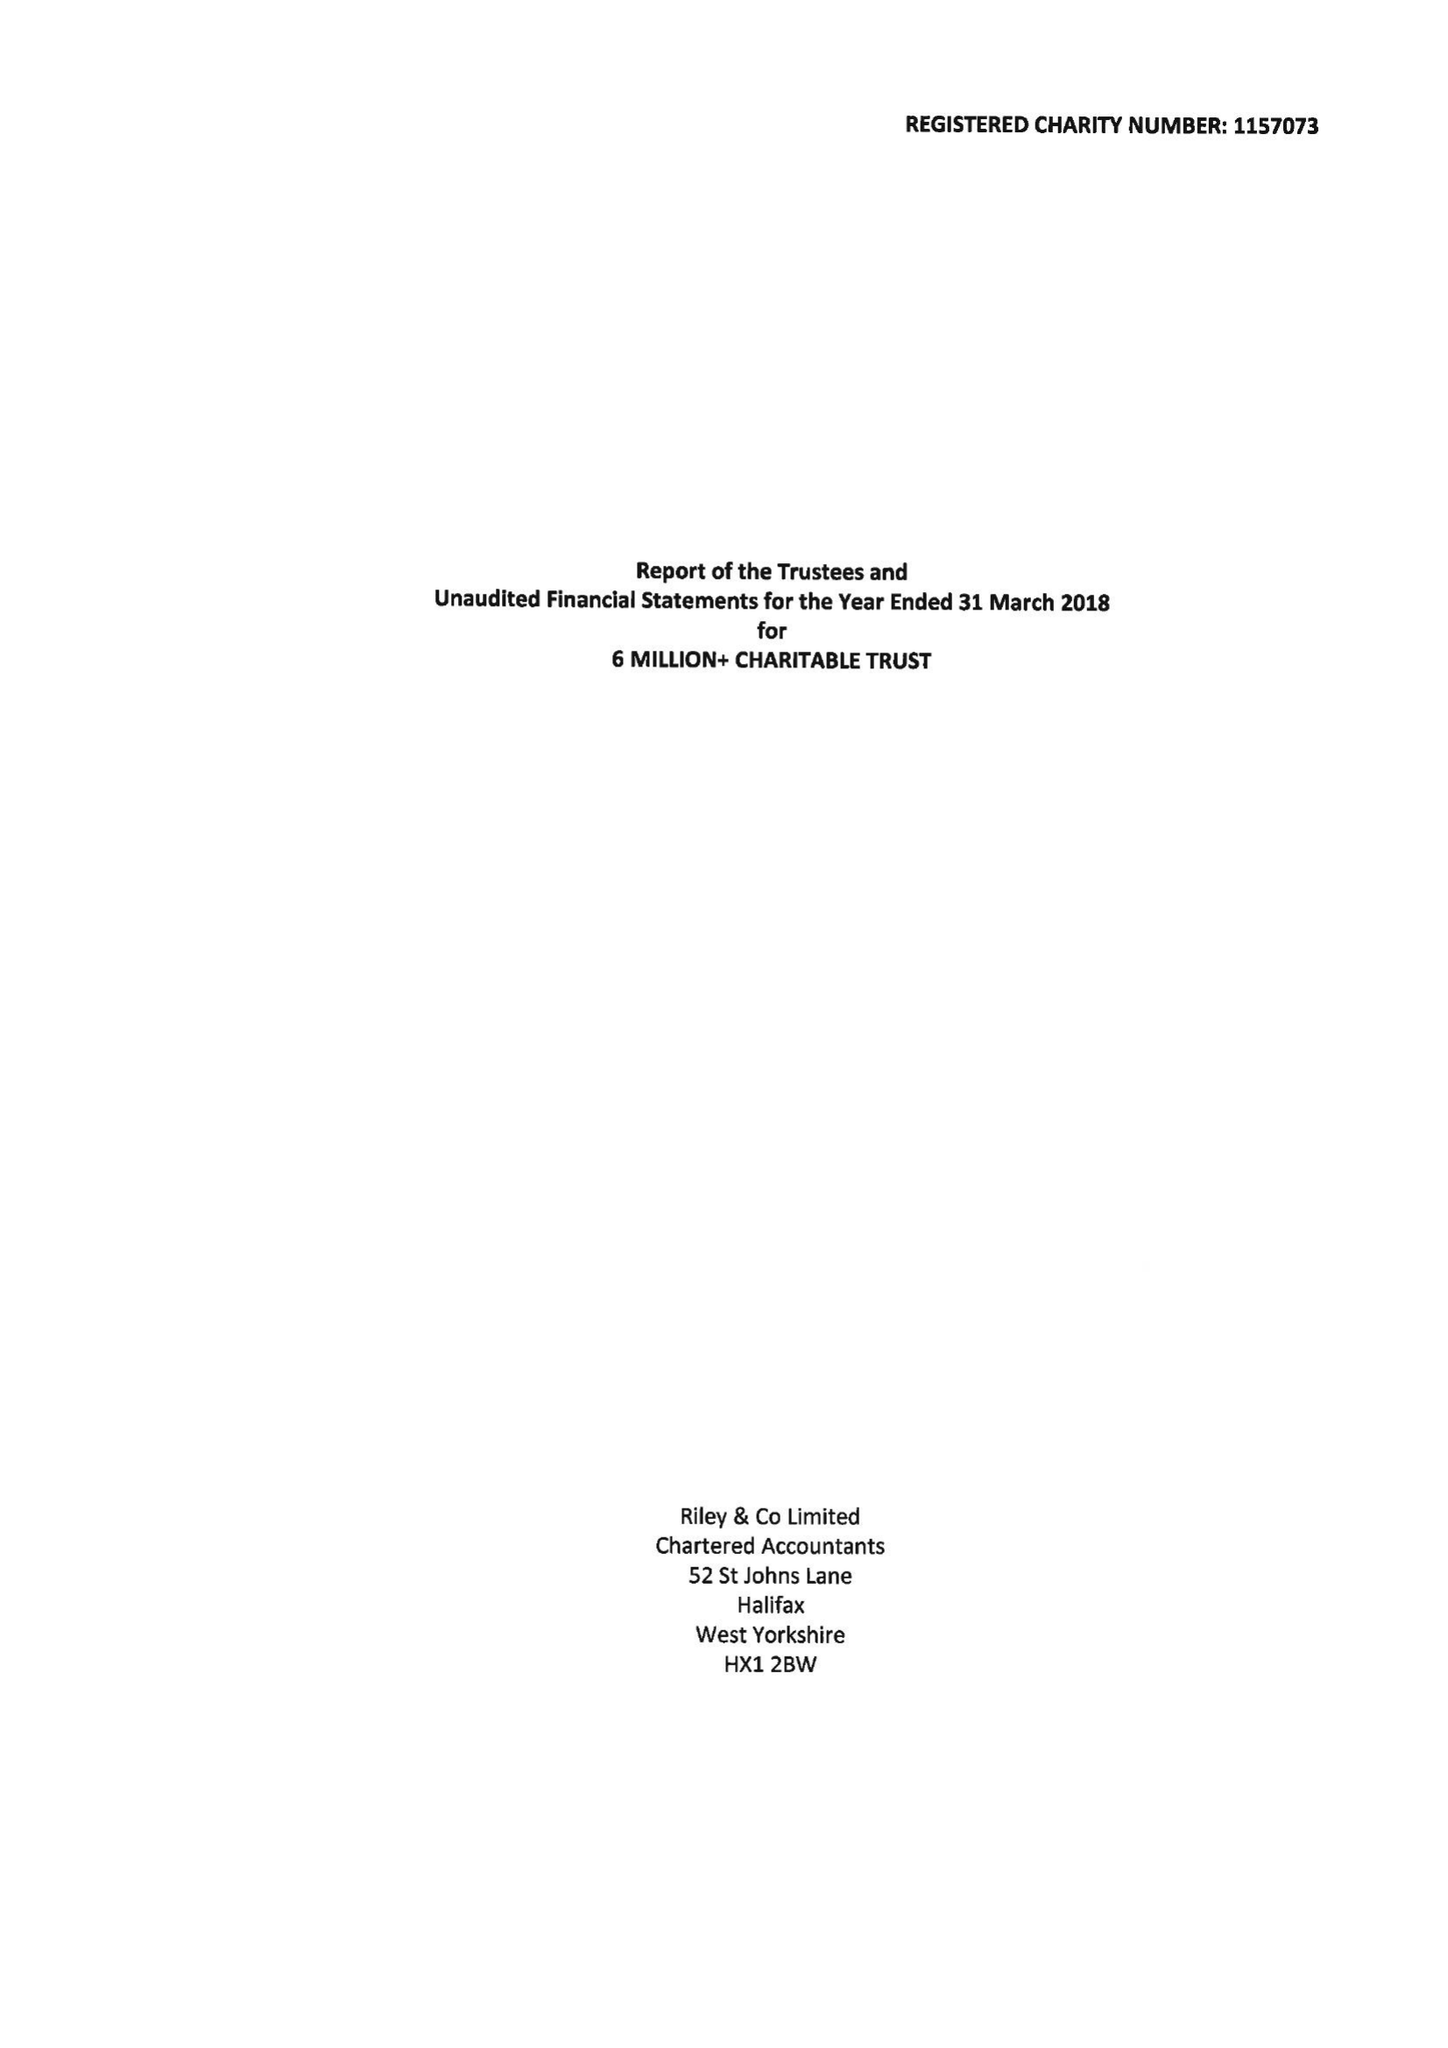What is the value for the spending_annually_in_british_pounds?
Answer the question using a single word or phrase. 71796.00 